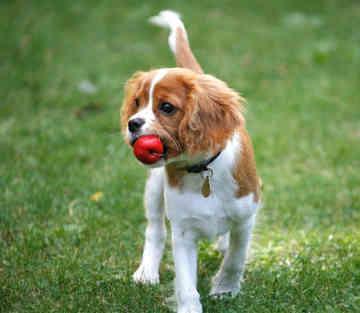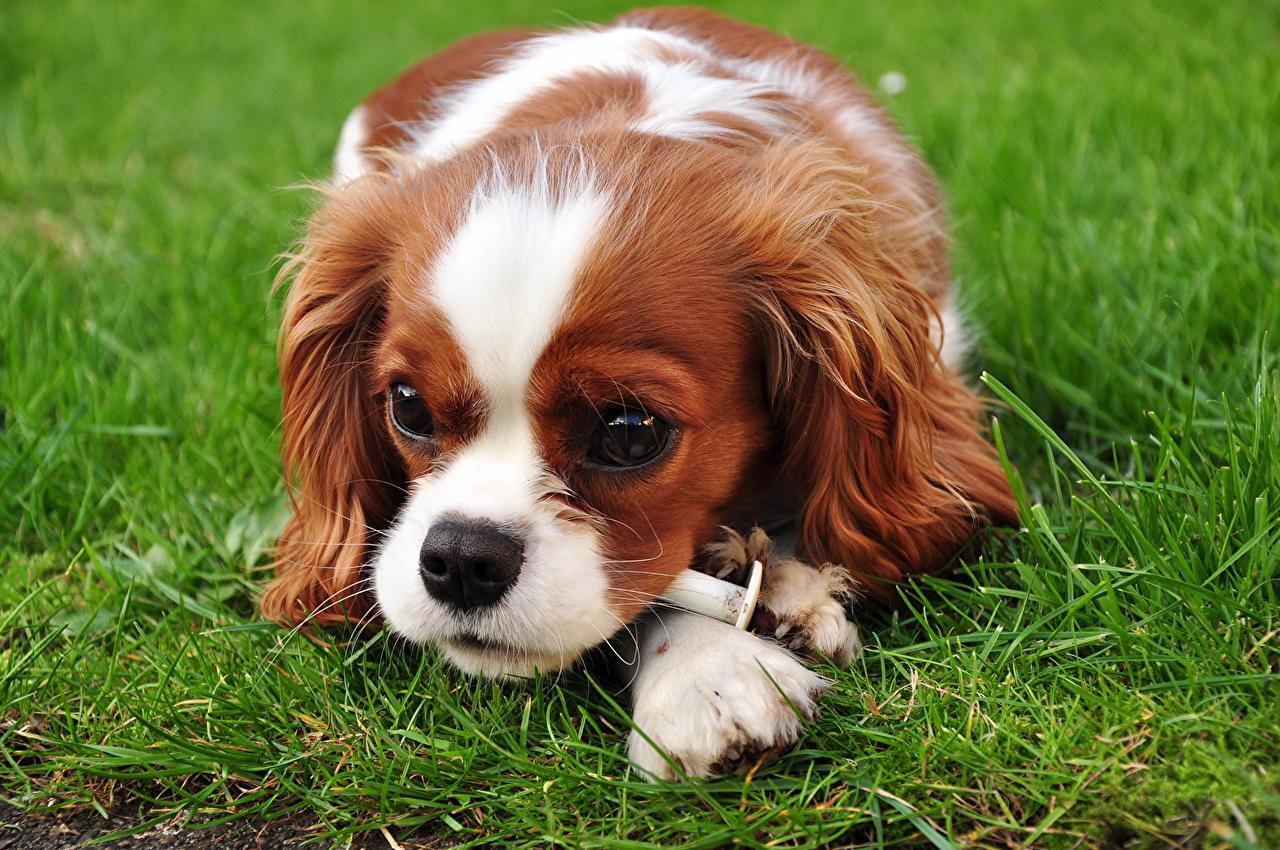The first image is the image on the left, the second image is the image on the right. Analyze the images presented: Is the assertion "Dogs are laying down inside a home" valid? Answer yes or no. No. The first image is the image on the left, the second image is the image on the right. Considering the images on both sides, is "Each image shows one brown and white dog on green grass." valid? Answer yes or no. Yes. 